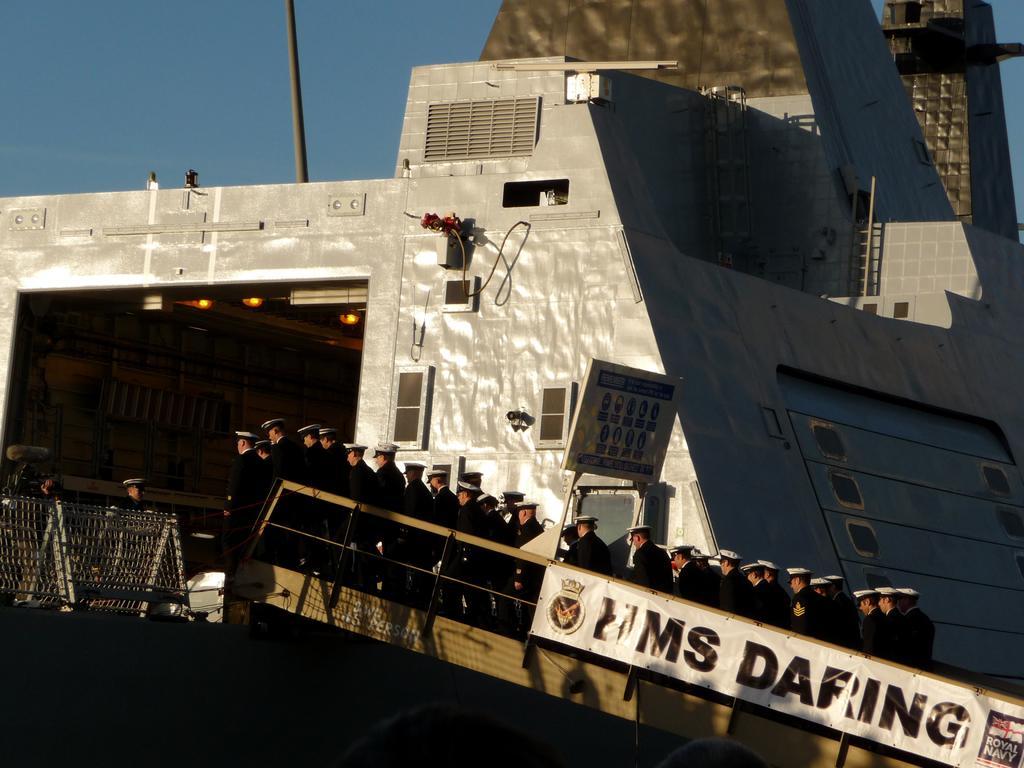How would you summarize this image in a sentence or two? In the image there is a ship and there are a group of navy officers standing in a row in the front. They are wearing black dress and white hats. 